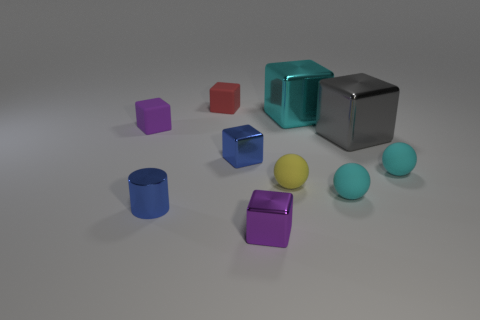Subtract all tiny purple rubber blocks. How many blocks are left? 5 Subtract all cyan spheres. How many spheres are left? 1 Subtract 2 spheres. How many spheres are left? 1 Add 4 big spheres. How many big spheres exist? 4 Subtract 0 brown blocks. How many objects are left? 10 Subtract all cylinders. How many objects are left? 9 Subtract all brown balls. Subtract all purple cubes. How many balls are left? 3 Subtract all brown cubes. How many yellow spheres are left? 1 Subtract all small purple matte things. Subtract all tiny things. How many objects are left? 1 Add 1 small red matte blocks. How many small red matte blocks are left? 2 